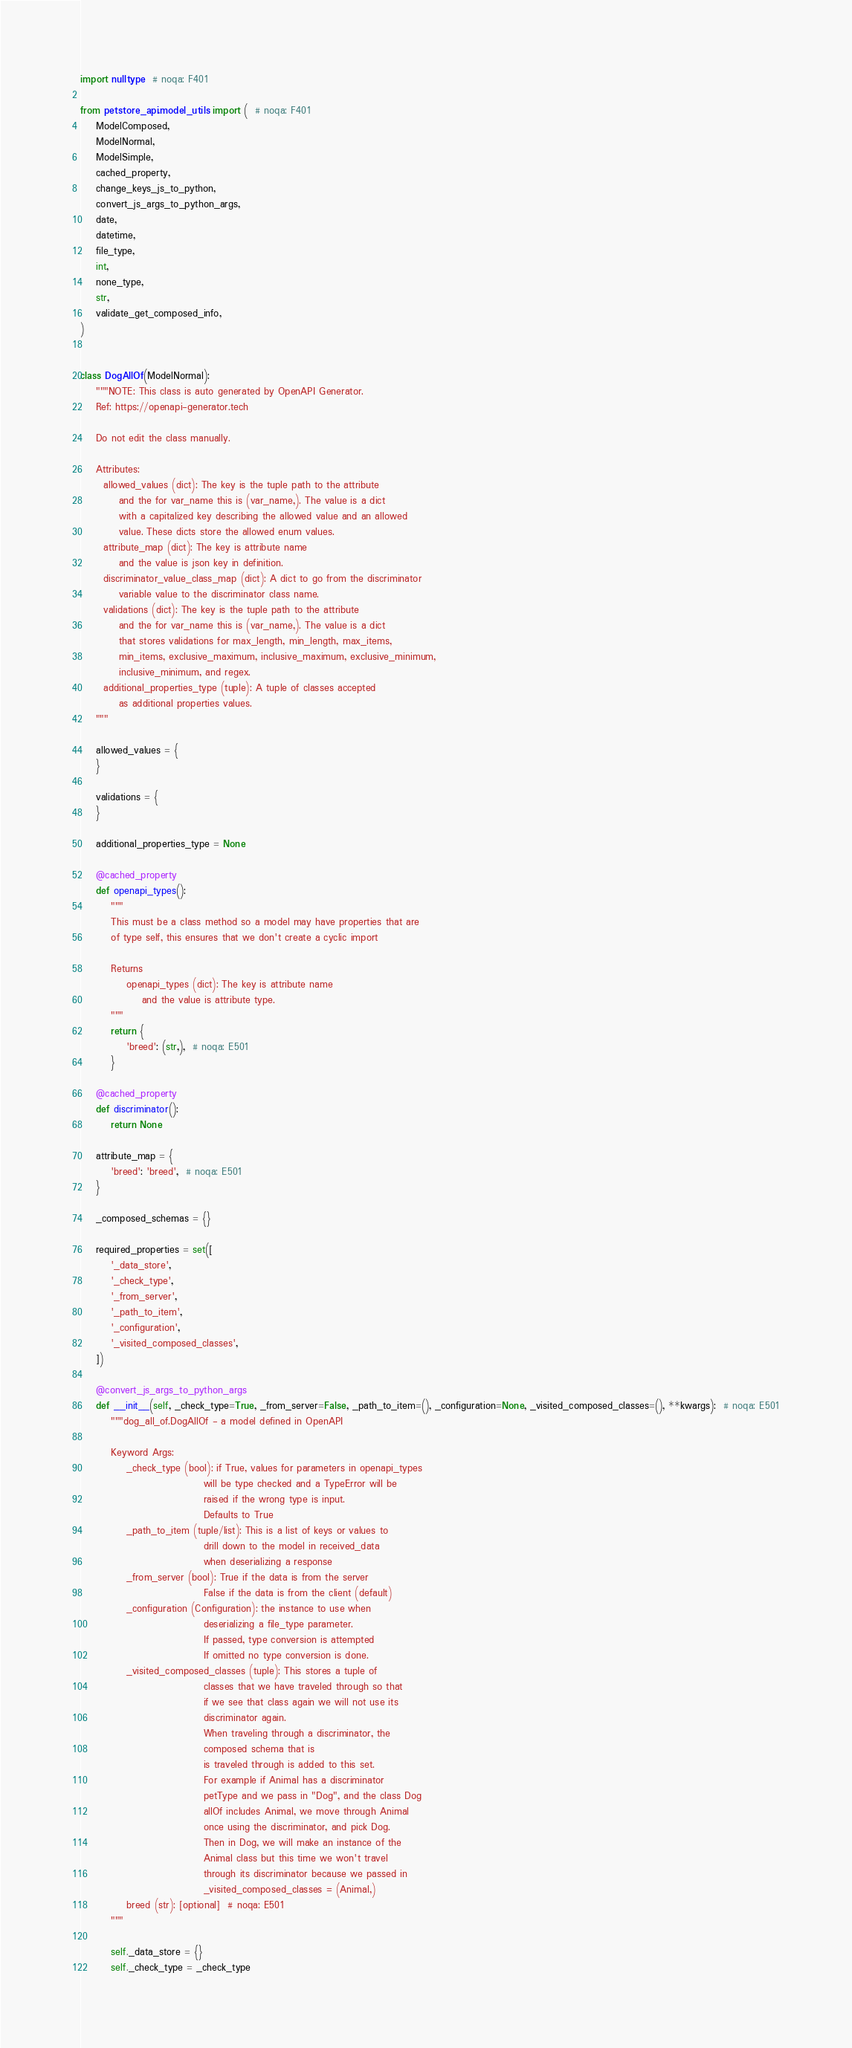<code> <loc_0><loc_0><loc_500><loc_500><_Python_>import nulltype  # noqa: F401

from petstore_api.model_utils import (  # noqa: F401
    ModelComposed,
    ModelNormal,
    ModelSimple,
    cached_property,
    change_keys_js_to_python,
    convert_js_args_to_python_args,
    date,
    datetime,
    file_type,
    int,
    none_type,
    str,
    validate_get_composed_info,
)


class DogAllOf(ModelNormal):
    """NOTE: This class is auto generated by OpenAPI Generator.
    Ref: https://openapi-generator.tech

    Do not edit the class manually.

    Attributes:
      allowed_values (dict): The key is the tuple path to the attribute
          and the for var_name this is (var_name,). The value is a dict
          with a capitalized key describing the allowed value and an allowed
          value. These dicts store the allowed enum values.
      attribute_map (dict): The key is attribute name
          and the value is json key in definition.
      discriminator_value_class_map (dict): A dict to go from the discriminator
          variable value to the discriminator class name.
      validations (dict): The key is the tuple path to the attribute
          and the for var_name this is (var_name,). The value is a dict
          that stores validations for max_length, min_length, max_items,
          min_items, exclusive_maximum, inclusive_maximum, exclusive_minimum,
          inclusive_minimum, and regex.
      additional_properties_type (tuple): A tuple of classes accepted
          as additional properties values.
    """

    allowed_values = {
    }

    validations = {
    }

    additional_properties_type = None

    @cached_property
    def openapi_types():
        """
        This must be a class method so a model may have properties that are
        of type self, this ensures that we don't create a cyclic import

        Returns
            openapi_types (dict): The key is attribute name
                and the value is attribute type.
        """
        return {
            'breed': (str,),  # noqa: E501
        }

    @cached_property
    def discriminator():
        return None

    attribute_map = {
        'breed': 'breed',  # noqa: E501
    }

    _composed_schemas = {}

    required_properties = set([
        '_data_store',
        '_check_type',
        '_from_server',
        '_path_to_item',
        '_configuration',
        '_visited_composed_classes',
    ])

    @convert_js_args_to_python_args
    def __init__(self, _check_type=True, _from_server=False, _path_to_item=(), _configuration=None, _visited_composed_classes=(), **kwargs):  # noqa: E501
        """dog_all_of.DogAllOf - a model defined in OpenAPI

        Keyword Args:
            _check_type (bool): if True, values for parameters in openapi_types
                                will be type checked and a TypeError will be
                                raised if the wrong type is input.
                                Defaults to True
            _path_to_item (tuple/list): This is a list of keys or values to
                                drill down to the model in received_data
                                when deserializing a response
            _from_server (bool): True if the data is from the server
                                False if the data is from the client (default)
            _configuration (Configuration): the instance to use when
                                deserializing a file_type parameter.
                                If passed, type conversion is attempted
                                If omitted no type conversion is done.
            _visited_composed_classes (tuple): This stores a tuple of
                                classes that we have traveled through so that
                                if we see that class again we will not use its
                                discriminator again.
                                When traveling through a discriminator, the
                                composed schema that is
                                is traveled through is added to this set.
                                For example if Animal has a discriminator
                                petType and we pass in "Dog", and the class Dog
                                allOf includes Animal, we move through Animal
                                once using the discriminator, and pick Dog.
                                Then in Dog, we will make an instance of the
                                Animal class but this time we won't travel
                                through its discriminator because we passed in
                                _visited_composed_classes = (Animal,)
            breed (str): [optional]  # noqa: E501
        """

        self._data_store = {}
        self._check_type = _check_type</code> 